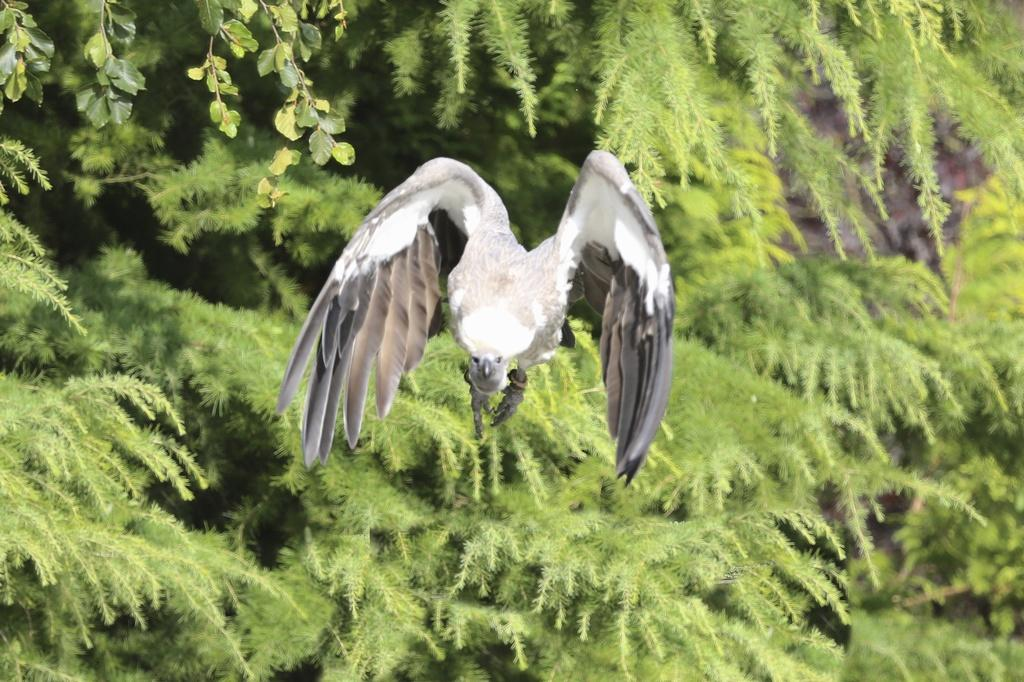What is the main subject of the image? There is a bird in the center of the image. Can you describe the bird's appearance? The bird is grey and white in color. What can be seen in the background of the image? There are trees in the background of the image. What type of snake can be seen slithering through the wilderness in the image? There is no snake present in the image; it features a bird and trees in the background. 